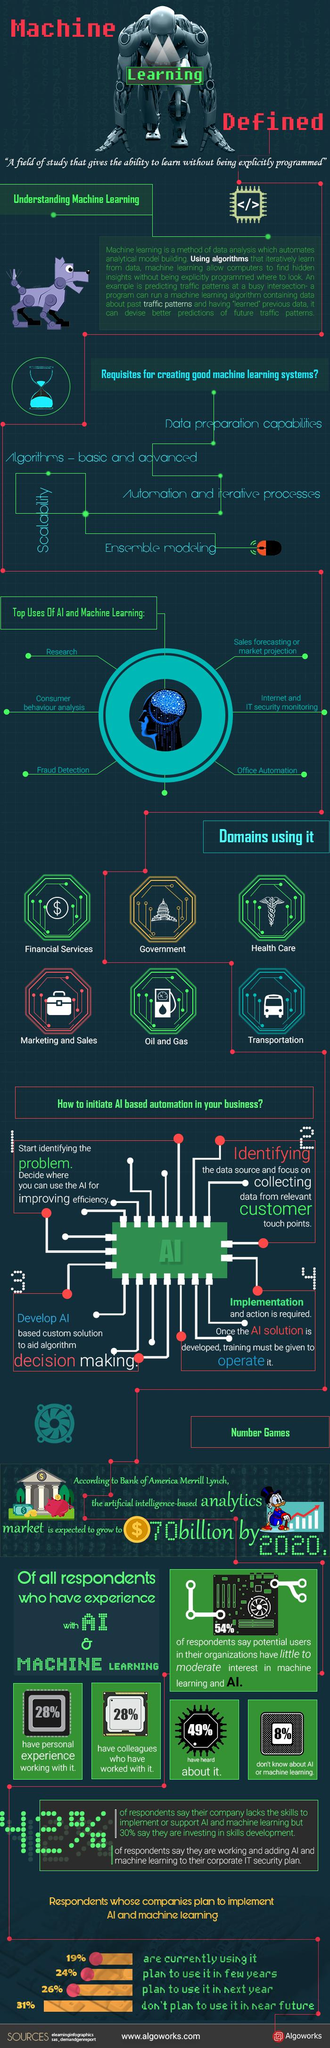Identify some key points in this picture. Six top uses of AI and machine learning have been given. According to the survey, 42% of the respondents stated that their company lacks the necessary skills to implement or support AI. According to the survey results, 50% of respondents plan to use the company's product in the next year and in a few years. It is necessary to fulfill five requirements to create an effective machine learning system. According to a recent survey, 72% of people do not have personal experience working with AI. 